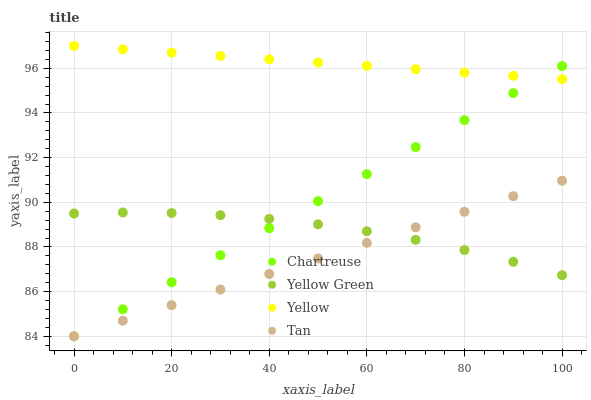Does Tan have the minimum area under the curve?
Answer yes or no. Yes. Does Yellow have the maximum area under the curve?
Answer yes or no. Yes. Does Yellow Green have the minimum area under the curve?
Answer yes or no. No. Does Yellow Green have the maximum area under the curve?
Answer yes or no. No. Is Chartreuse the smoothest?
Answer yes or no. Yes. Is Yellow Green the roughest?
Answer yes or no. Yes. Is Yellow Green the smoothest?
Answer yes or no. No. Is Tan the roughest?
Answer yes or no. No. Does Chartreuse have the lowest value?
Answer yes or no. Yes. Does Yellow Green have the lowest value?
Answer yes or no. No. Does Yellow have the highest value?
Answer yes or no. Yes. Does Tan have the highest value?
Answer yes or no. No. Is Tan less than Yellow?
Answer yes or no. Yes. Is Yellow greater than Yellow Green?
Answer yes or no. Yes. Does Yellow intersect Chartreuse?
Answer yes or no. Yes. Is Yellow less than Chartreuse?
Answer yes or no. No. Is Yellow greater than Chartreuse?
Answer yes or no. No. Does Tan intersect Yellow?
Answer yes or no. No. 